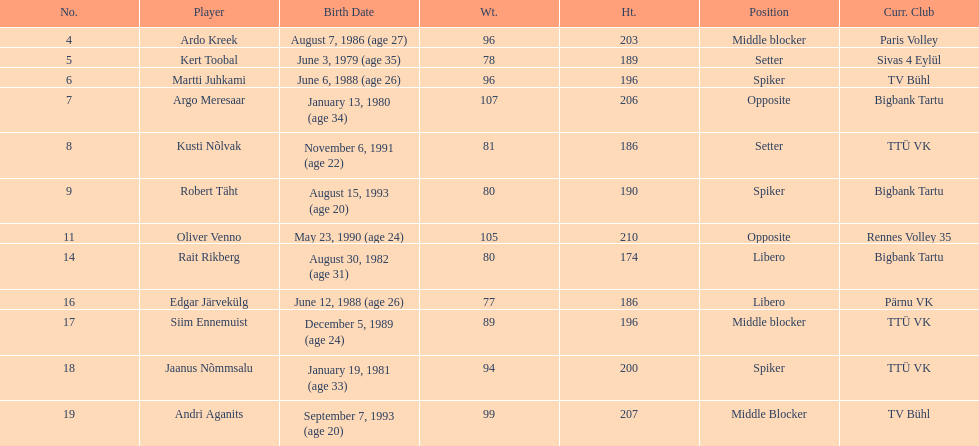Who is at least 25 years or older? Ardo Kreek, Kert Toobal, Martti Juhkami, Argo Meresaar, Rait Rikberg, Edgar Järvekülg, Jaanus Nõmmsalu. 